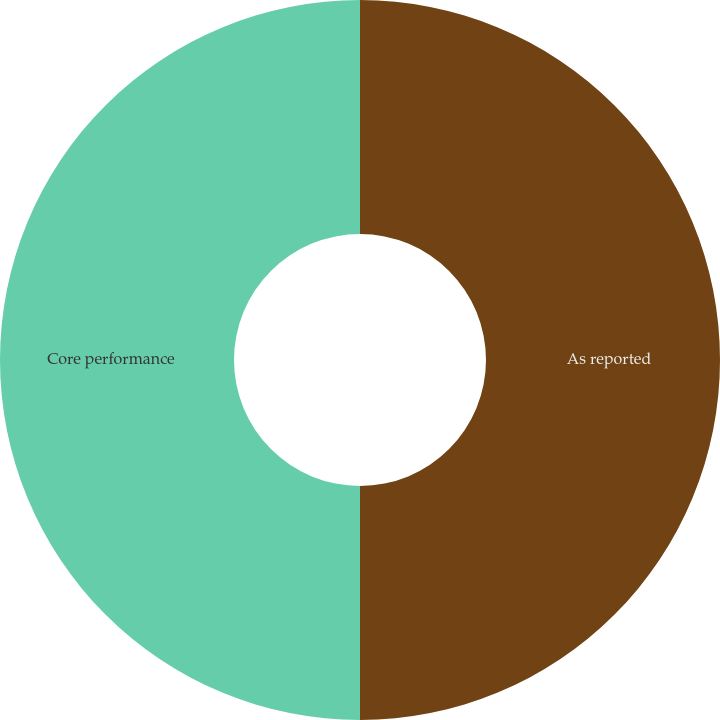<chart> <loc_0><loc_0><loc_500><loc_500><pie_chart><fcel>As reported<fcel>Core performance<nl><fcel>50.0%<fcel>50.0%<nl></chart> 